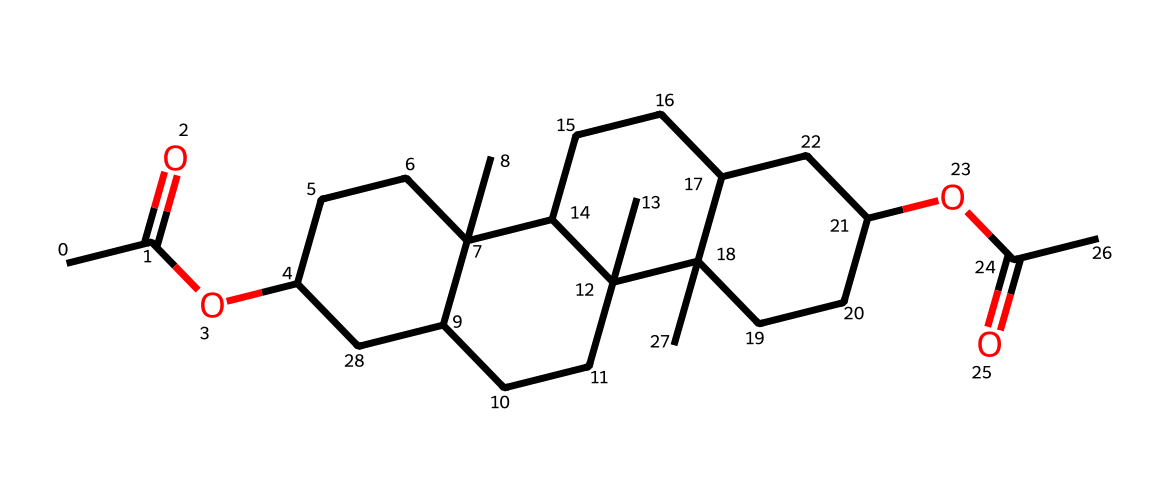What is the main functional group present in this compound? The main functional group in this compound is the ester group, indicated by the presence of the C(=O)OC structure, which features a carbonyl (C=O) linked to an oxygen.
Answer: ester How many carbon atoms are in this chemical? By analyzing the SMILES representation, we can count the total number of carbon atoms represented by 'C'. There are 30 carbon atoms visible in the entire structure.
Answer: 30 What type of cosmetic application might this compound be used for? Given its structural characteristics and common use in incense, this compound is often used for fragrance purposes in cosmetics, enhancing aromatic properties.
Answer: fragrance Is there a cyclic structure present in this compound? Yes, upon examining the structure indicated by the "C1" and "C2" numbers in the SMILES representation, we see that there are cyclic components, which are characteristic of polycyclic structures.
Answer: yes What is the relationship between this compound and incense used in Catholic ceremonies? This compound’s structure is characteristic of essential oils and resins derived from natural sources, commonly used in incense to enhance spiritual experiences and create a calming atmosphere during liturgical rituals.
Answer: aromatic Does this compound contain any heteroatoms? Yes, the structure contains oxygen atoms, which are heteroatoms represented in the SMILES format and appear in functional groups such as esters.
Answer: yes What is the implication of the ester functional group in this compound? The ester functional group typically implies pleasant fragrances and low volatility, contributing to the compound's suitability as an aromatic agent in incense.
Answer: pleasant fragrance 